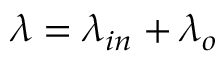Convert formula to latex. <formula><loc_0><loc_0><loc_500><loc_500>\lambda = \lambda _ { i n } + \lambda _ { o }</formula> 